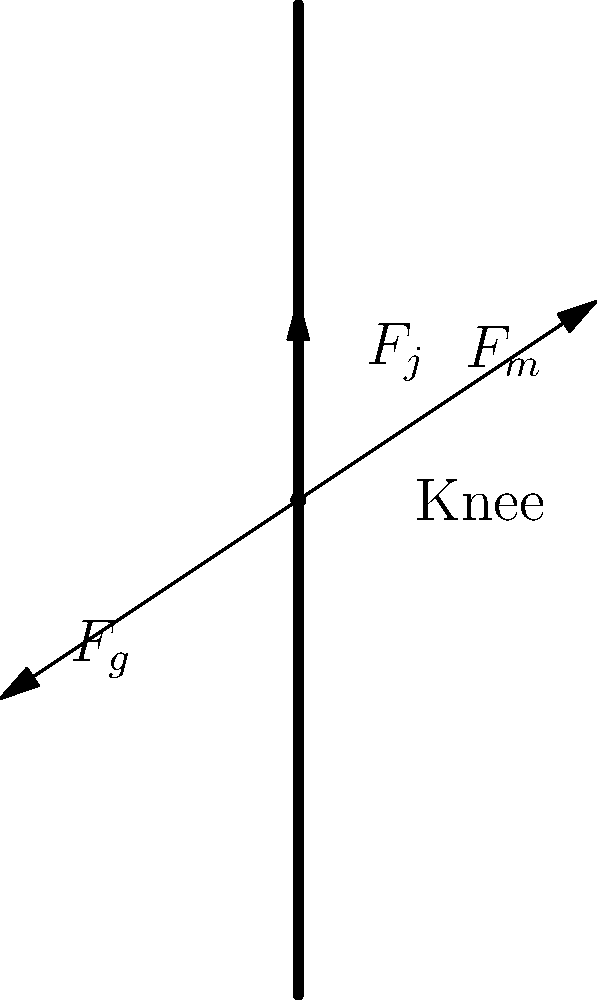As a sceptical employee of Netlifi, you're reviewing a biomechanical analysis of knee forces during movement. The diagram shows three forces acting on the knee joint: muscle force ($F_m$), gravitational force ($F_g$), and joint reaction force ($F_j$). If the magnitude of $F_m$ is 500N and $F_g$ is 300N, what is the magnitude of $F_j$ required to maintain equilibrium, assuming all forces act in the plane shown? To solve this problem, we need to follow these steps:

1. Recognize that for the knee to be in equilibrium, the sum of all forces must equal zero.

2. Decompose the forces into vertical components:
   $F_m$ (vertical) = $500 \sin(45°) = 500 * 0.707 = 353.55$ N (upward)
   $F_g$ = 300 N (downward)
   $F_j$ is already vertical (upward)

3. Set up the equilibrium equation:
   $\sum F_y = 0$
   $F_j + F_m(\text{vertical}) - F_g = 0$

4. Substitute the known values:
   $F_j + 353.55 - 300 = 0$

5. Solve for $F_j$:
   $F_j = 300 - 353.55 = -53.55$ N

6. The negative sign indicates that $F_j$ is actually pointing downward, contrary to our initial assumption. We can express this as a positive magnitude pointing downward.

Therefore, the magnitude of $F_j$ required to maintain equilibrium is 53.55 N, acting downward.
Answer: 53.55 N downward 